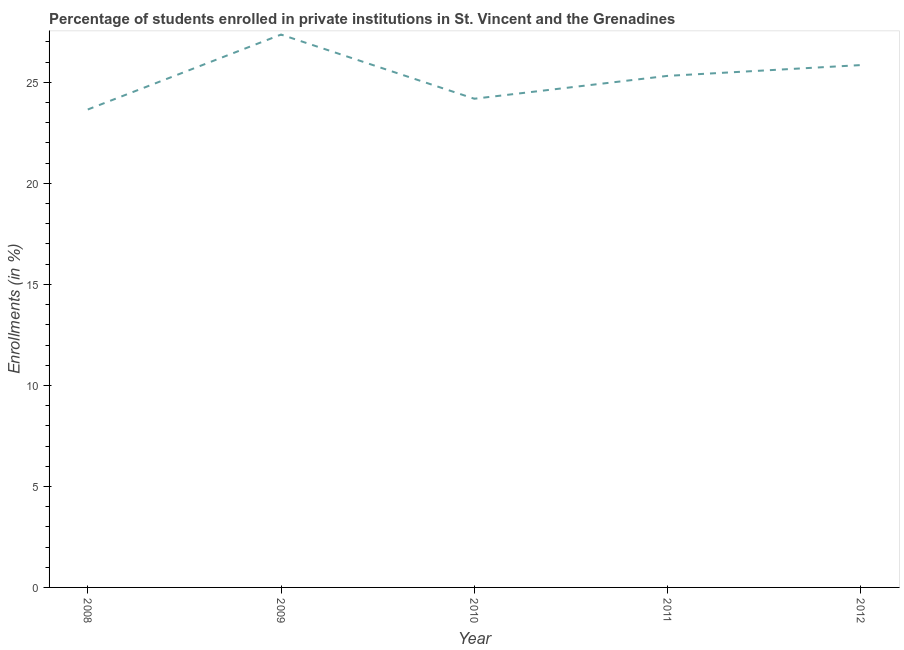What is the enrollments in private institutions in 2008?
Provide a succinct answer. 23.66. Across all years, what is the maximum enrollments in private institutions?
Your answer should be compact. 27.37. Across all years, what is the minimum enrollments in private institutions?
Provide a short and direct response. 23.66. In which year was the enrollments in private institutions maximum?
Make the answer very short. 2009. In which year was the enrollments in private institutions minimum?
Keep it short and to the point. 2008. What is the sum of the enrollments in private institutions?
Give a very brief answer. 126.39. What is the difference between the enrollments in private institutions in 2009 and 2012?
Ensure brevity in your answer.  1.51. What is the average enrollments in private institutions per year?
Your response must be concise. 25.28. What is the median enrollments in private institutions?
Give a very brief answer. 25.32. In how many years, is the enrollments in private institutions greater than 21 %?
Offer a very short reply. 5. What is the ratio of the enrollments in private institutions in 2009 to that in 2012?
Provide a short and direct response. 1.06. Is the enrollments in private institutions in 2009 less than that in 2010?
Make the answer very short. No. What is the difference between the highest and the second highest enrollments in private institutions?
Your answer should be compact. 1.51. Is the sum of the enrollments in private institutions in 2010 and 2012 greater than the maximum enrollments in private institutions across all years?
Your answer should be compact. Yes. What is the difference between the highest and the lowest enrollments in private institutions?
Ensure brevity in your answer.  3.71. How many years are there in the graph?
Keep it short and to the point. 5. Does the graph contain grids?
Your response must be concise. No. What is the title of the graph?
Keep it short and to the point. Percentage of students enrolled in private institutions in St. Vincent and the Grenadines. What is the label or title of the X-axis?
Provide a succinct answer. Year. What is the label or title of the Y-axis?
Give a very brief answer. Enrollments (in %). What is the Enrollments (in %) of 2008?
Provide a short and direct response. 23.66. What is the Enrollments (in %) in 2009?
Keep it short and to the point. 27.37. What is the Enrollments (in %) in 2010?
Keep it short and to the point. 24.19. What is the Enrollments (in %) in 2011?
Give a very brief answer. 25.32. What is the Enrollments (in %) in 2012?
Provide a short and direct response. 25.86. What is the difference between the Enrollments (in %) in 2008 and 2009?
Give a very brief answer. -3.71. What is the difference between the Enrollments (in %) in 2008 and 2010?
Ensure brevity in your answer.  -0.53. What is the difference between the Enrollments (in %) in 2008 and 2011?
Offer a very short reply. -1.66. What is the difference between the Enrollments (in %) in 2008 and 2012?
Give a very brief answer. -2.2. What is the difference between the Enrollments (in %) in 2009 and 2010?
Give a very brief answer. 3.18. What is the difference between the Enrollments (in %) in 2009 and 2011?
Your answer should be very brief. 2.04. What is the difference between the Enrollments (in %) in 2009 and 2012?
Keep it short and to the point. 1.51. What is the difference between the Enrollments (in %) in 2010 and 2011?
Your answer should be compact. -1.13. What is the difference between the Enrollments (in %) in 2010 and 2012?
Give a very brief answer. -1.67. What is the difference between the Enrollments (in %) in 2011 and 2012?
Your answer should be very brief. -0.53. What is the ratio of the Enrollments (in %) in 2008 to that in 2009?
Give a very brief answer. 0.86. What is the ratio of the Enrollments (in %) in 2008 to that in 2011?
Your response must be concise. 0.93. What is the ratio of the Enrollments (in %) in 2008 to that in 2012?
Make the answer very short. 0.92. What is the ratio of the Enrollments (in %) in 2009 to that in 2010?
Provide a succinct answer. 1.13. What is the ratio of the Enrollments (in %) in 2009 to that in 2011?
Ensure brevity in your answer.  1.08. What is the ratio of the Enrollments (in %) in 2009 to that in 2012?
Provide a succinct answer. 1.06. What is the ratio of the Enrollments (in %) in 2010 to that in 2011?
Your response must be concise. 0.95. What is the ratio of the Enrollments (in %) in 2010 to that in 2012?
Make the answer very short. 0.94. 